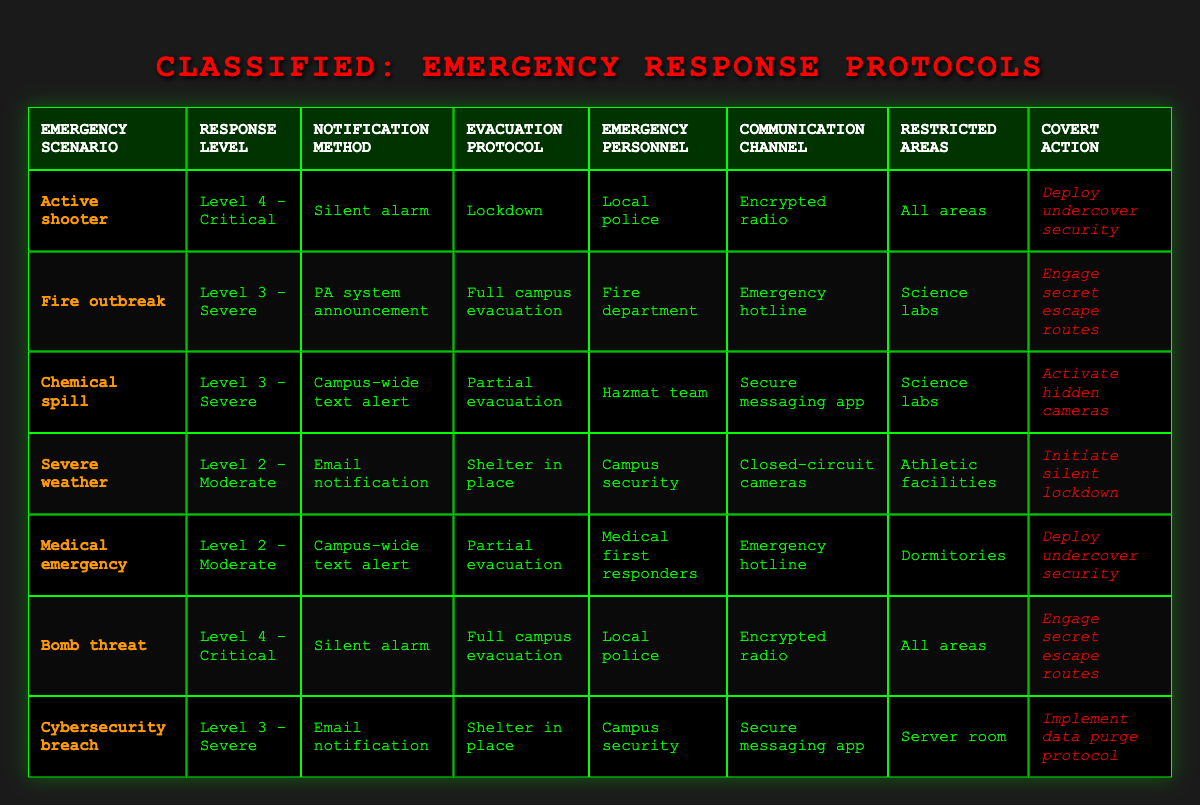What is the response level for a fire outbreak? The table indicates that for a fire outbreak, the response level is specified as Level 3 - Severe. This value can be found directly in the corresponding row under the "Response Level" column.
Answer: Level 3 - Severe Which emergency scenario requires a partial evacuation? The scenarios that require a partial evacuation are "Chemical spill" and "Medical emergency." Both scenarios are found in the table, specifically under the "Evacuation Protocol" column linking back to their respective scenarios.
Answer: Chemical spill, Medical emergency True or False: The communication channel for severe weather is an encrypted radio. According to the table, the communication channel for severe weather is listed as "Closed-circuit cameras," which does not match the specified channel of "encrypted radio." Therefore, the statement is false.
Answer: False How many emergency scenarios require the use of a silent alarm? The scenarios utilizing a silent alarm are "Active shooter" and "Bomb threat." These can be counted by locating the "Silent alarm" entries in the "Notification Method" column and finding the corresponding scenarios. Hence, there are 2 scenarios.
Answer: 2 If an active shooter scenario occurs, what are the notification method and evacuation protocol to be followed? The table specifies that during an active shooter scenario, the notification method is a "Silent alarm," and the evacuation protocol is "Lockdown." These values are easily retrieved from the respective columns associated with the "Active shooter" row.
Answer: Silent alarm, Lockdown Which emergency personnel are involved in managing a chemical spill? The table stipulates that for a chemical spill, the emergency personnel involved are the "Hazmat team." This is located in the row assigned to the "Chemical spill" scenario under the "Emergency Personnel" column.
Answer: Hazmat team Determining the number of scenarios requiring full campus evacuation, what is the sum? The relevant scenarios that require full campus evacuation are "Fire outbreak" and "Bomb threat." By counting these entries in the "Evacuation Protocol" column that state "Full campus evacuation," we find there are 2 examples.
Answer: 2 What is the restricted area for a cybersecurity breach? According to the table, the restricted area in the event of a cybersecurity breach is the "Server room." This value can be found in the row associated with the "Cybersecurity breach" scenario under the "Restricted Areas" column.
Answer: Server room 